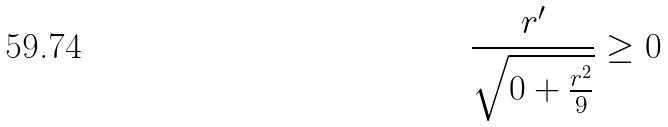<formula> <loc_0><loc_0><loc_500><loc_500>\frac { r ^ { \prime } } { \sqrt { 0 + \frac { r ^ { 2 } } { 9 } } } \geq 0</formula> 